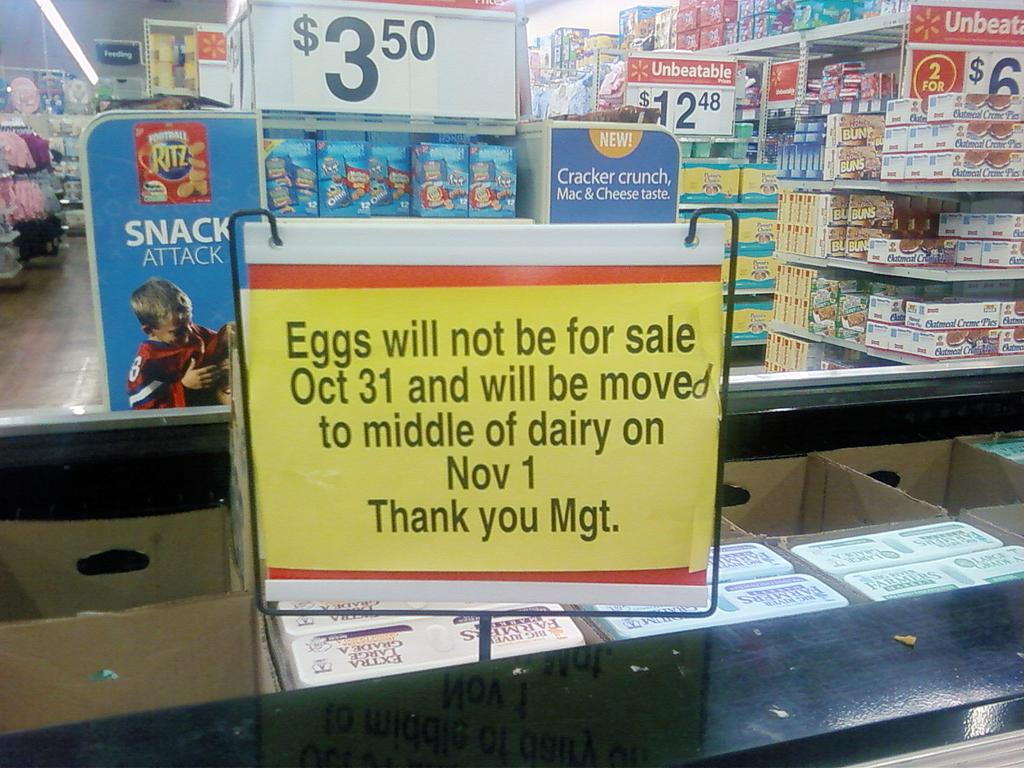What is the main object in the image? There is a board in the image. What other objects can be seen in the image? There are cardboard boxes in the image. Can you describe the colorful boxes in the background? The colorful boxes are in racks in the background of the image. What else can be seen in the background of the image? There are boards and lights visible in the background of the image. What type of texture can be seen on the engine in the image? There is no engine present in the image, so it is not possible to determine the texture. 